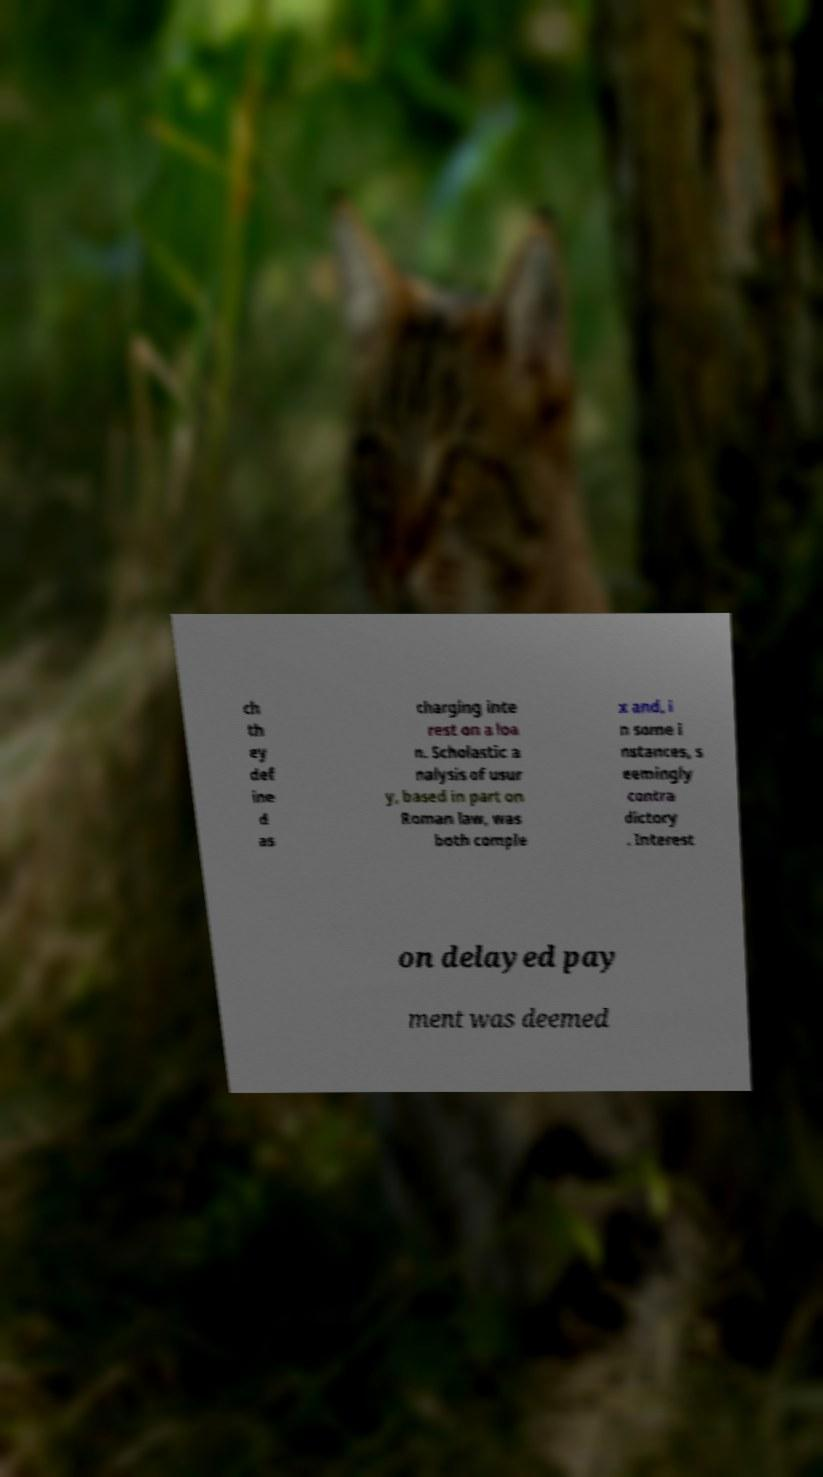Please identify and transcribe the text found in this image. ch th ey def ine d as charging inte rest on a loa n. Scholastic a nalysis of usur y, based in part on Roman law, was both comple x and, i n some i nstances, s eemingly contra dictory . Interest on delayed pay ment was deemed 